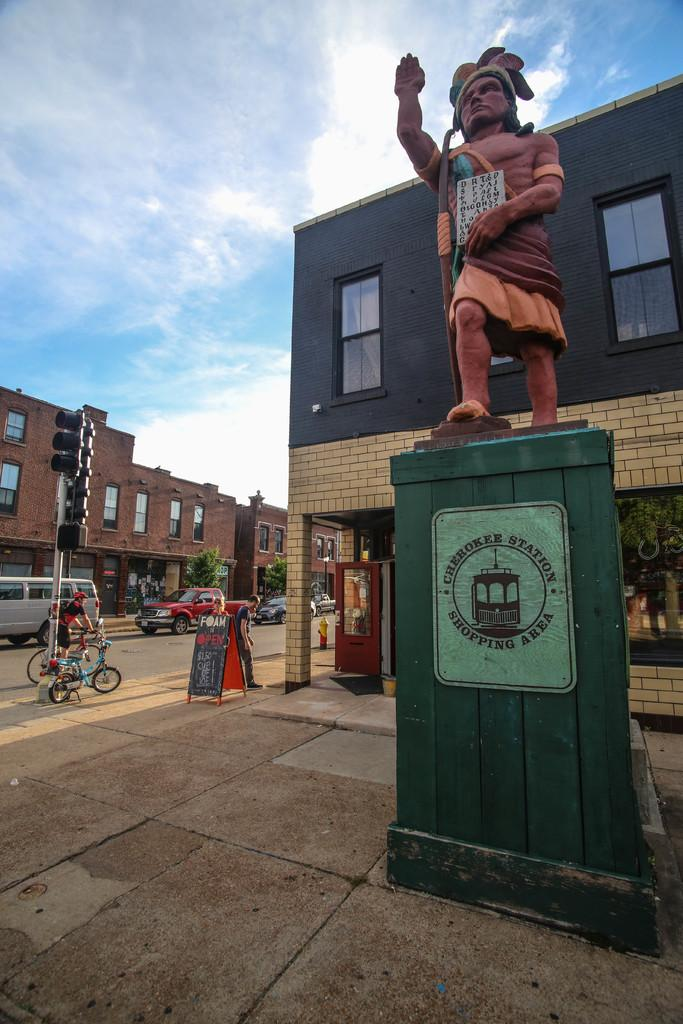What is the main subject in the image? There is a statue in the image. What else can be seen in the image besides the statue? There are buildings, a traffic signal, cars, bicycles, people, and a banner in the image. What mode of transportation is visible in the image? Cars and bicycles are visible in the image. What is the condition of the sky in the image? The sky is visible at the top of the image. What type of coach can be seen in the image? There is no coach present in the image. What town is depicted in the image? The image does not depict a specific town; it shows a statue, buildings, and other elements in an urban setting. 